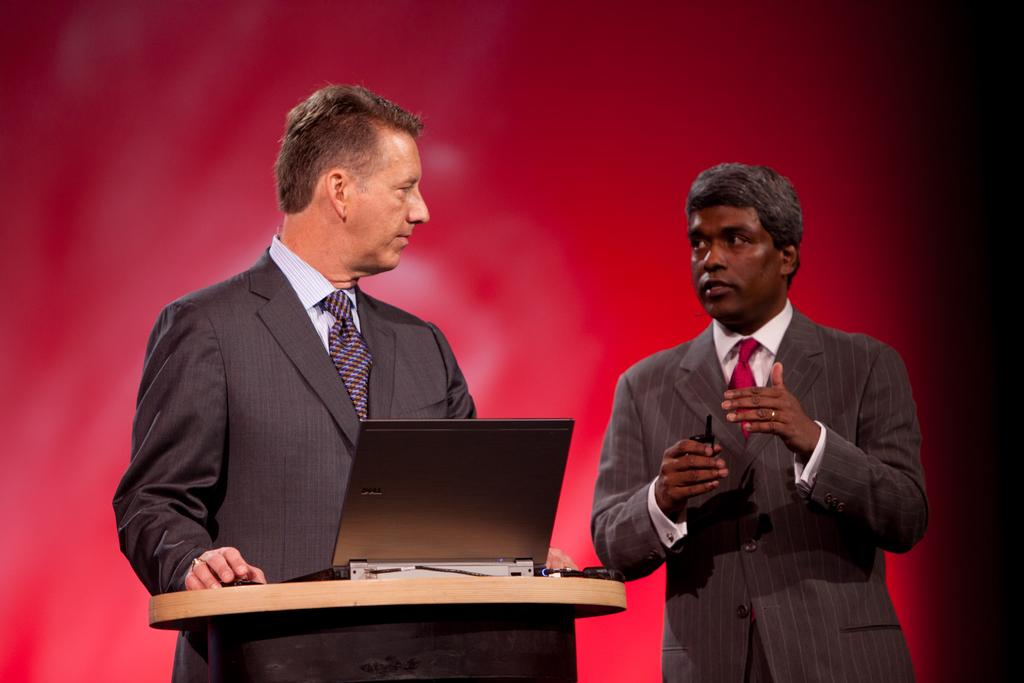How many people are at the podium in the image? There are two men standing at the podium in the image. What electronic device is on the podium? There is a laptop on the podium. Are there any cords or cables visible on the podium? Yes, there are cables on the podium. What can be seen in the background of the image? There is a red color object in the background of the image. Is there steam coming from the laptop in the image? No, there is no steam visible in the image. What type of garden can be seen in the background of the image? There is there a garden present in the image? 